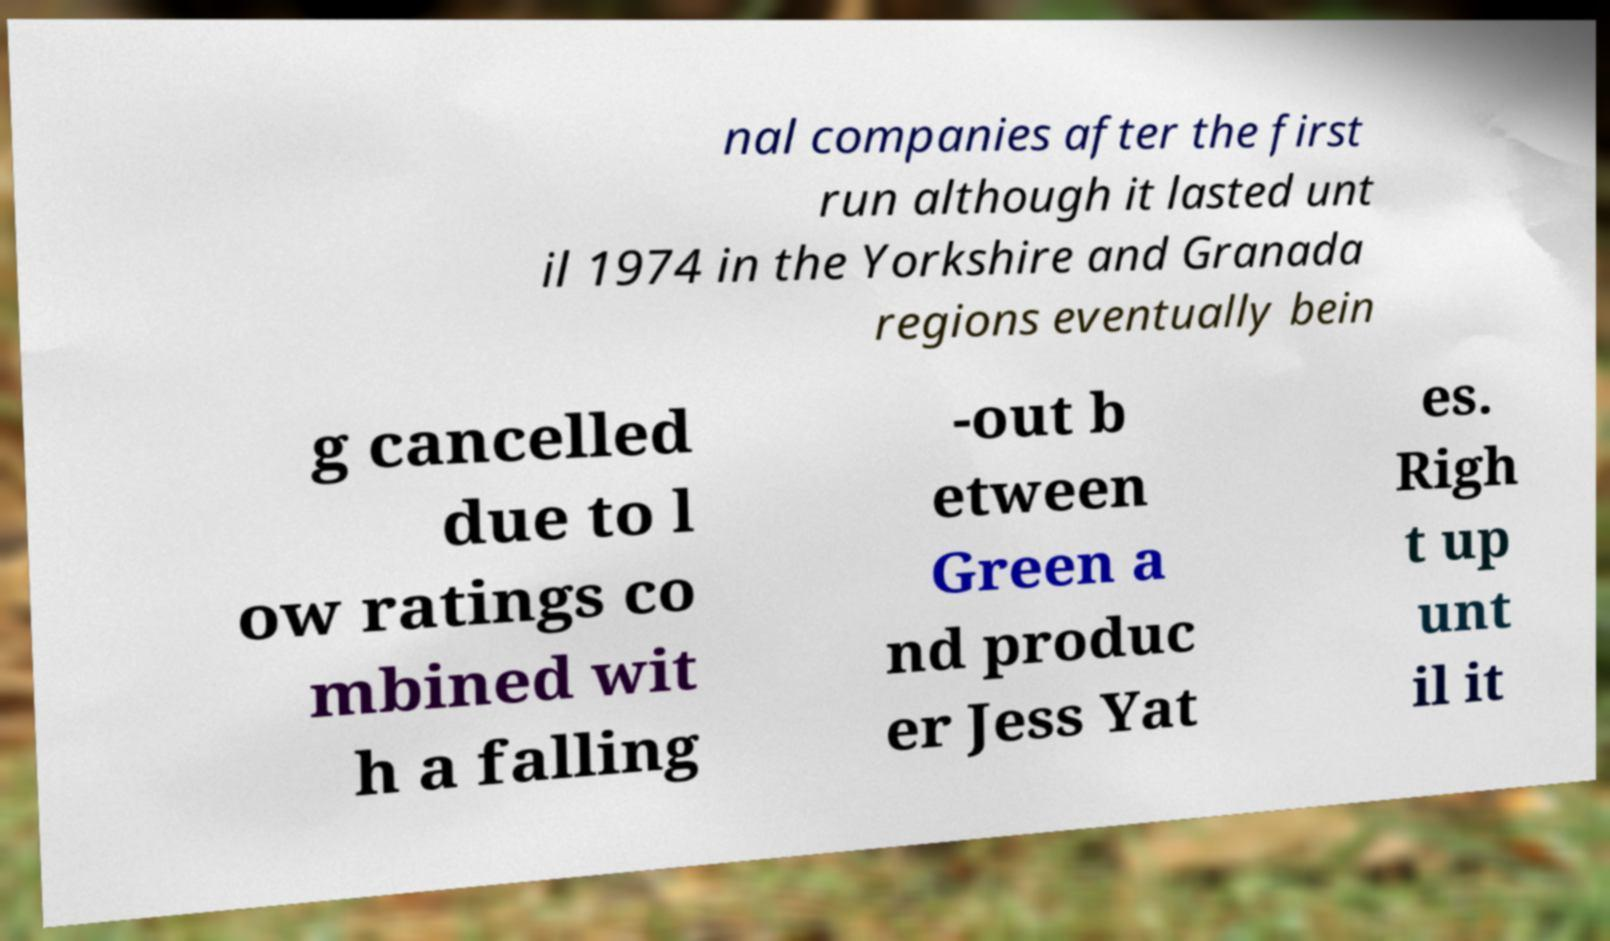Please identify and transcribe the text found in this image. nal companies after the first run although it lasted unt il 1974 in the Yorkshire and Granada regions eventually bein g cancelled due to l ow ratings co mbined wit h a falling -out b etween Green a nd produc er Jess Yat es. Righ t up unt il it 